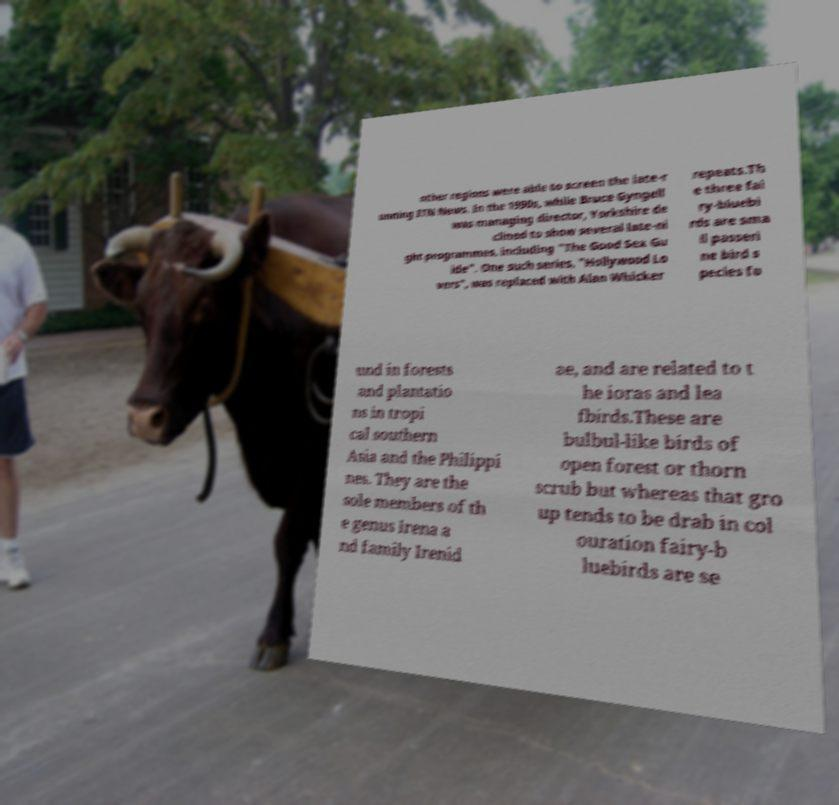Please identify and transcribe the text found in this image. other regions were able to screen the late-r unning ITN News. In the 1990s, while Bruce Gyngell was managing director, Yorkshire de clined to show several late-ni ght programmes, including "The Good Sex Gu ide". One such series, "Hollywood Lo vers", was replaced with Alan Whicker repeats.Th e three fai ry-bluebi rds are sma ll passeri ne bird s pecies fo und in forests and plantatio ns in tropi cal southern Asia and the Philippi nes. They are the sole members of th e genus Irena a nd family Irenid ae, and are related to t he ioras and lea fbirds.These are bulbul-like birds of open forest or thorn scrub but whereas that gro up tends to be drab in col ouration fairy-b luebirds are se 